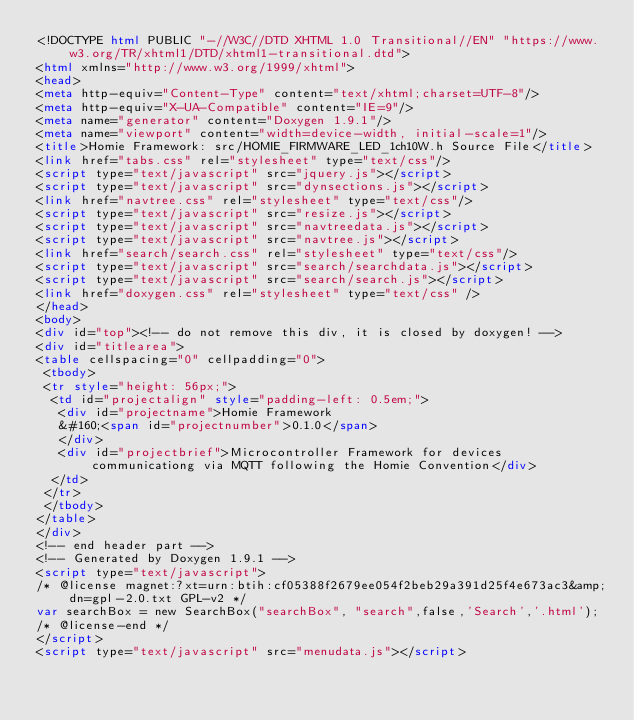<code> <loc_0><loc_0><loc_500><loc_500><_HTML_><!DOCTYPE html PUBLIC "-//W3C//DTD XHTML 1.0 Transitional//EN" "https://www.w3.org/TR/xhtml1/DTD/xhtml1-transitional.dtd">
<html xmlns="http://www.w3.org/1999/xhtml">
<head>
<meta http-equiv="Content-Type" content="text/xhtml;charset=UTF-8"/>
<meta http-equiv="X-UA-Compatible" content="IE=9"/>
<meta name="generator" content="Doxygen 1.9.1"/>
<meta name="viewport" content="width=device-width, initial-scale=1"/>
<title>Homie Framework: src/HOMIE_FIRMWARE_LED_1ch10W.h Source File</title>
<link href="tabs.css" rel="stylesheet" type="text/css"/>
<script type="text/javascript" src="jquery.js"></script>
<script type="text/javascript" src="dynsections.js"></script>
<link href="navtree.css" rel="stylesheet" type="text/css"/>
<script type="text/javascript" src="resize.js"></script>
<script type="text/javascript" src="navtreedata.js"></script>
<script type="text/javascript" src="navtree.js"></script>
<link href="search/search.css" rel="stylesheet" type="text/css"/>
<script type="text/javascript" src="search/searchdata.js"></script>
<script type="text/javascript" src="search/search.js"></script>
<link href="doxygen.css" rel="stylesheet" type="text/css" />
</head>
<body>
<div id="top"><!-- do not remove this div, it is closed by doxygen! -->
<div id="titlearea">
<table cellspacing="0" cellpadding="0">
 <tbody>
 <tr style="height: 56px;">
  <td id="projectalign" style="padding-left: 0.5em;">
   <div id="projectname">Homie Framework
   &#160;<span id="projectnumber">0.1.0</span>
   </div>
   <div id="projectbrief">Microcontroller Framework for devices communicationg via MQTT following the Homie Convention</div>
  </td>
 </tr>
 </tbody>
</table>
</div>
<!-- end header part -->
<!-- Generated by Doxygen 1.9.1 -->
<script type="text/javascript">
/* @license magnet:?xt=urn:btih:cf05388f2679ee054f2beb29a391d25f4e673ac3&amp;dn=gpl-2.0.txt GPL-v2 */
var searchBox = new SearchBox("searchBox", "search",false,'Search','.html');
/* @license-end */
</script>
<script type="text/javascript" src="menudata.js"></script></code> 